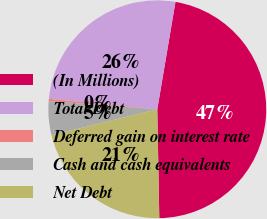Convert chart. <chart><loc_0><loc_0><loc_500><loc_500><pie_chart><fcel>(In Millions)<fcel>Total Debt<fcel>Deferred gain on interest rate<fcel>Cash and cash equivalents<fcel>Net Debt<nl><fcel>47.04%<fcel>26.13%<fcel>0.35%<fcel>5.02%<fcel>21.46%<nl></chart> 